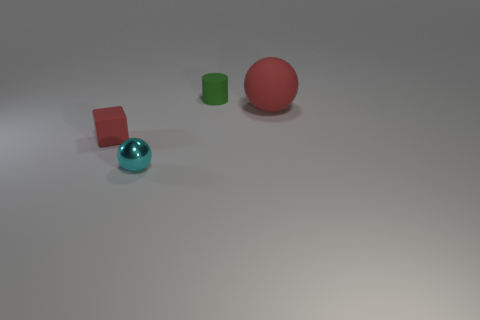Is there any other thing that is the same size as the rubber sphere?
Provide a succinct answer. No. What material is the cyan thing that is the same size as the red matte block?
Your response must be concise. Metal. There is a red matte thing that is to the right of the red object that is left of the small matte object behind the large red thing; how big is it?
Give a very brief answer. Large. There is a cube that is made of the same material as the big object; what size is it?
Your response must be concise. Small. There is a matte ball; is it the same size as the sphere in front of the red block?
Provide a succinct answer. No. There is a red rubber object that is left of the tiny ball; what is its shape?
Keep it short and to the point. Cube. There is a small matte cylinder that is to the right of the matte thing to the left of the shiny thing; are there any metal things behind it?
Keep it short and to the point. No. There is a big red object that is the same shape as the small shiny object; what is it made of?
Offer a terse response. Rubber. Is there any other thing that has the same material as the small cyan thing?
Make the answer very short. No. How many balls are either red objects or big objects?
Offer a terse response. 1. 